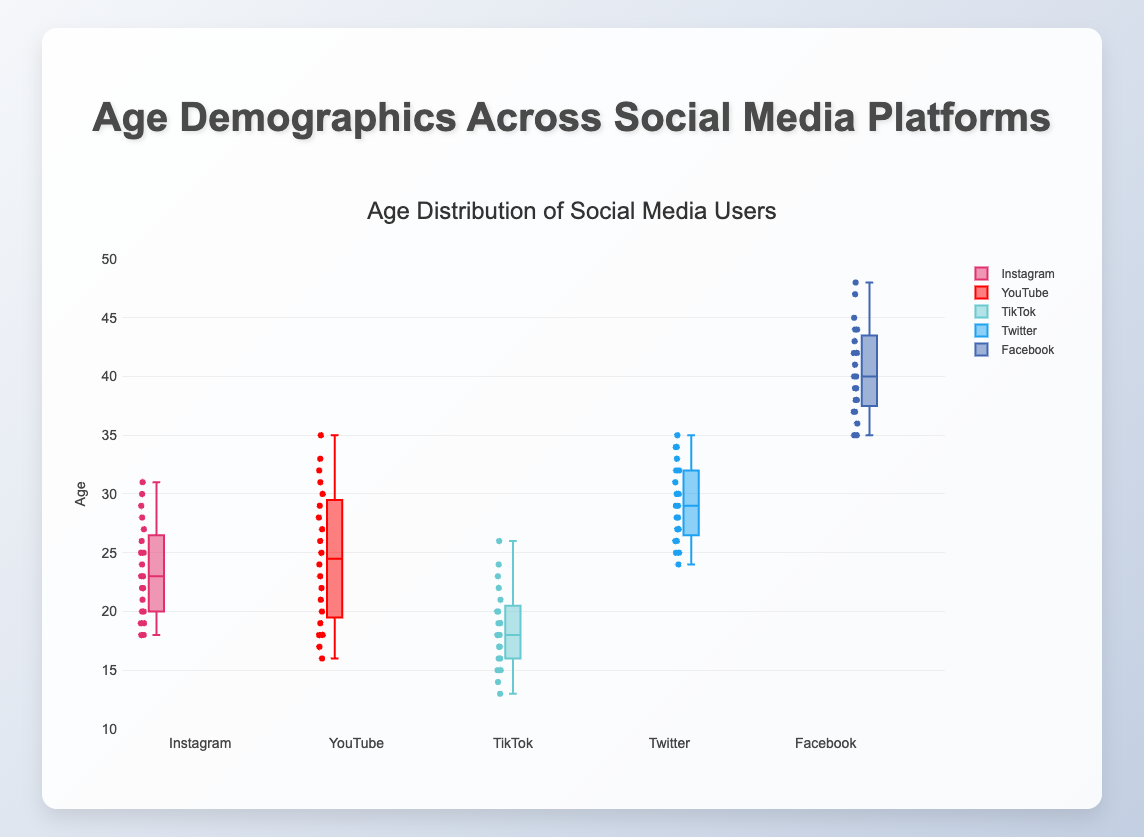What is the title of the figure? The title of the figure is located at the top and provides an overview of what the figure is about.
Answer: Age Distribution of Social Media Users What are the platforms included in the box plot? The box plot groups data based on different social media platforms, usually indicated by separate box plots for each platform.
Answer: Instagram, YouTube, TikTok, Twitter, Facebook Which platform has the youngest median age? To determine this, compare the median lines (middle line in each box) of each platform's box plot to see which one is the lowest.
Answer: TikTok Which platform shows the most variability in age? The variability in age can be assessed by looking at the range and interquartile range (IQR) of the box plots, identifying which one has the widest spread.
Answer: Facebook What is the age range of Twitter users? The age range can be identified by the minimum and maximum whiskers (lines extending from the box) for Twitter.
Answer: 25 to 35 Which platform's age group appears to be centered around young adults (20-30 years)? Platforms with a median and interquartile range within the 20-30 years range indicate a focus on young adults.
Answer: Instagram, YouTube Is the median age of Facebook users higher than that of Twitter users? Compare the central median lines of the Facebook and Twitter box plots.
Answer: Yes What is the interquartile range (IQR) for TikTok users? The IQR is the difference between the third quartile (top of the box) and the first quartile (bottom of the box) for the TikTok box plot.
Answer: 10 (20 - 10) How does the maximum age of YouTube users compare to that of Instagram users? Compare the maximum whisker (top line) of the YouTube box plot to the maximum whisker of the Instagram box plot.
Answer: YouTube's maximum age is higher Which platform has the oldest user base? Analyze which platform has both a higher median and a higher maximum whisker.
Answer: Facebook 